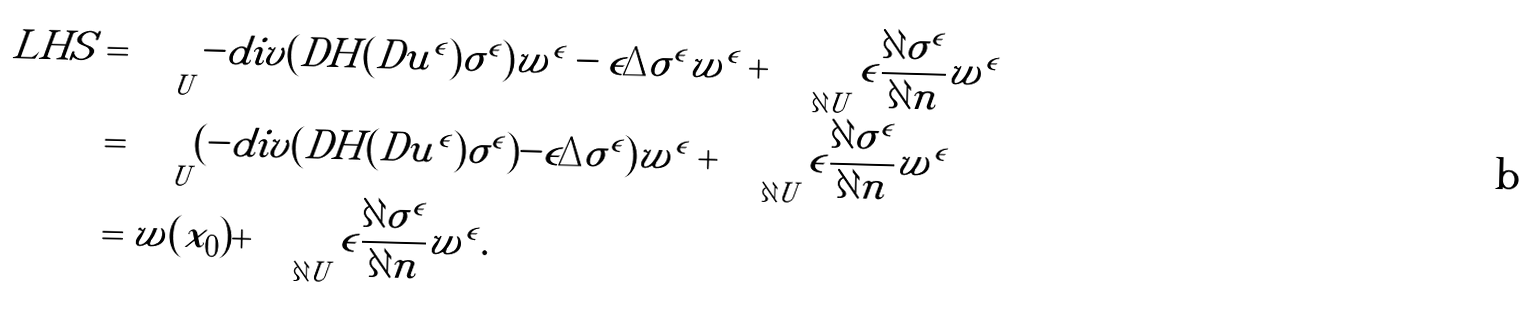<formula> <loc_0><loc_0><loc_500><loc_500>L H S & = \int _ { U } - d i v ( D H ( D u ^ { \epsilon } ) \sigma ^ { \epsilon } ) w ^ { \epsilon } - \epsilon \Delta \sigma ^ { \epsilon } w ^ { \epsilon } + \int _ { \partial U } \epsilon \frac { \partial \sigma ^ { \epsilon } } { \partial n } w ^ { \epsilon } \quad \\ & = \int _ { U } ( - d i v ( D H ( D u ^ { \epsilon } ) \sigma ^ { \epsilon } ) - \epsilon \Delta \sigma ^ { \epsilon } ) w ^ { \epsilon } + \int _ { \partial U } \epsilon \frac { \partial \sigma ^ { \epsilon } } { \partial n } w ^ { \epsilon } \quad \\ & = w ( x _ { 0 } ) + \int _ { \partial U } \epsilon \frac { \partial \sigma ^ { \epsilon } } { \partial n } w ^ { \epsilon } . \quad</formula> 